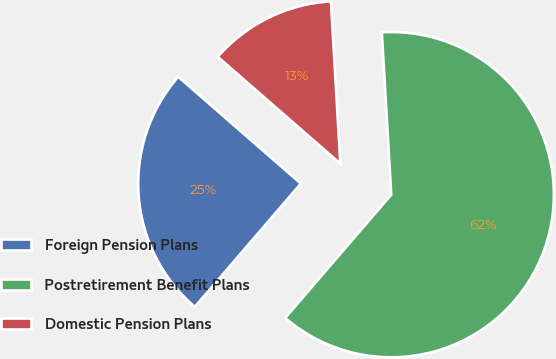<chart> <loc_0><loc_0><loc_500><loc_500><pie_chart><fcel>Foreign Pension Plans<fcel>Postretirement Benefit Plans<fcel>Domestic Pension Plans<nl><fcel>25.1%<fcel>62.23%<fcel>12.67%<nl></chart> 